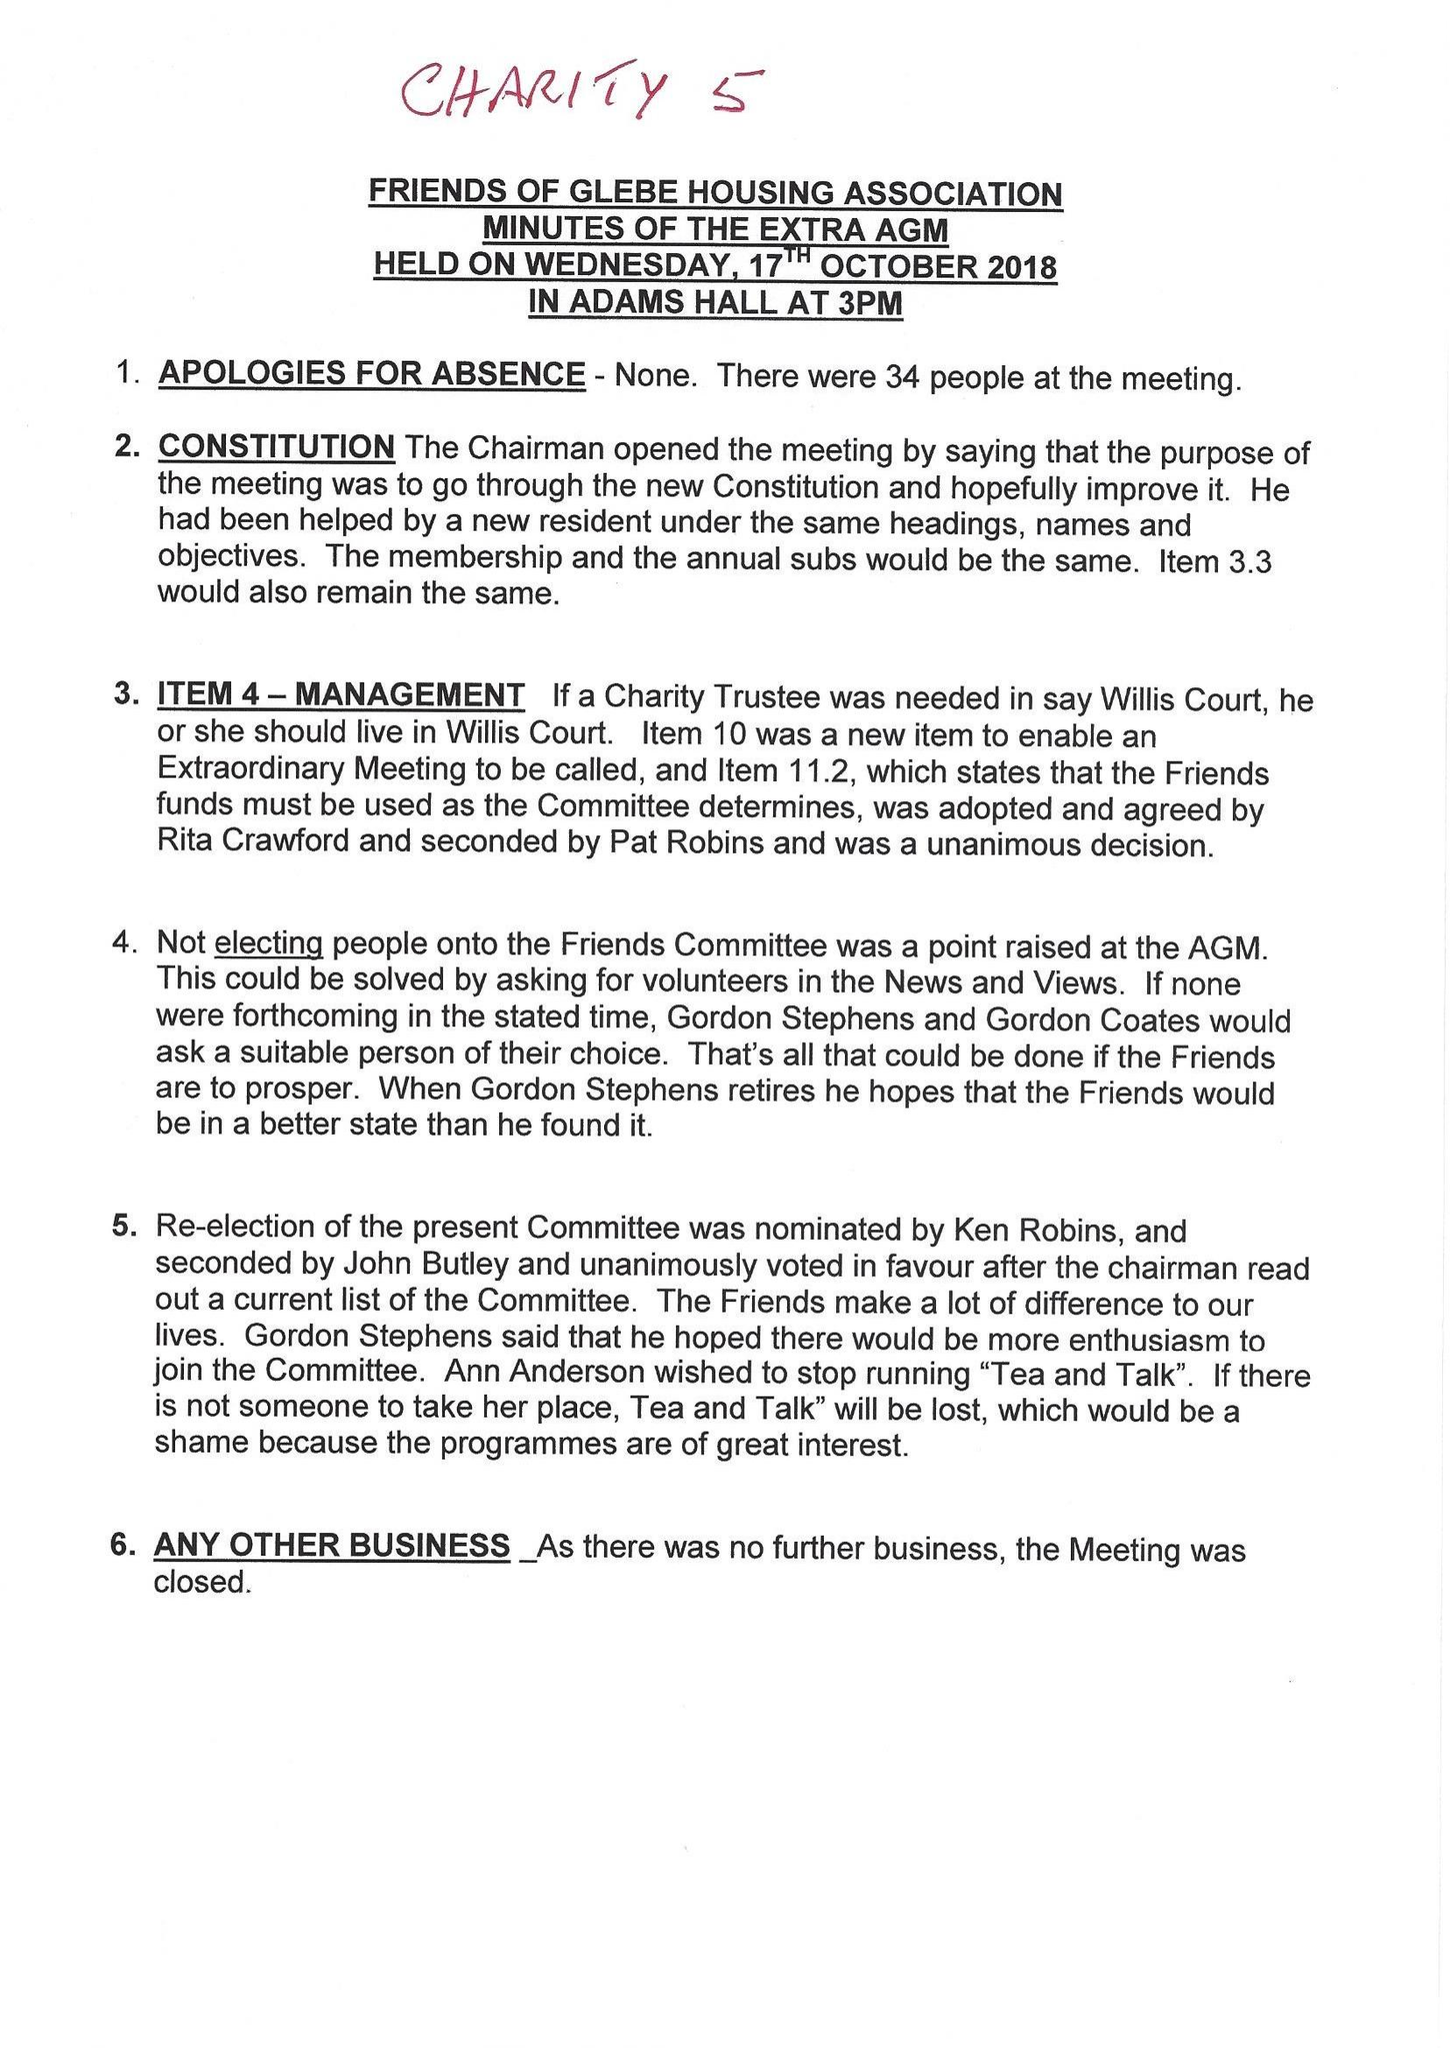What is the value for the spending_annually_in_british_pounds?
Answer the question using a single word or phrase. 53757.00 